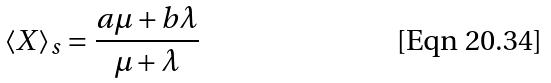Convert formula to latex. <formula><loc_0><loc_0><loc_500><loc_500>\langle X \rangle _ { s } = \frac { a \mu + b \lambda } { \mu + \lambda }</formula> 